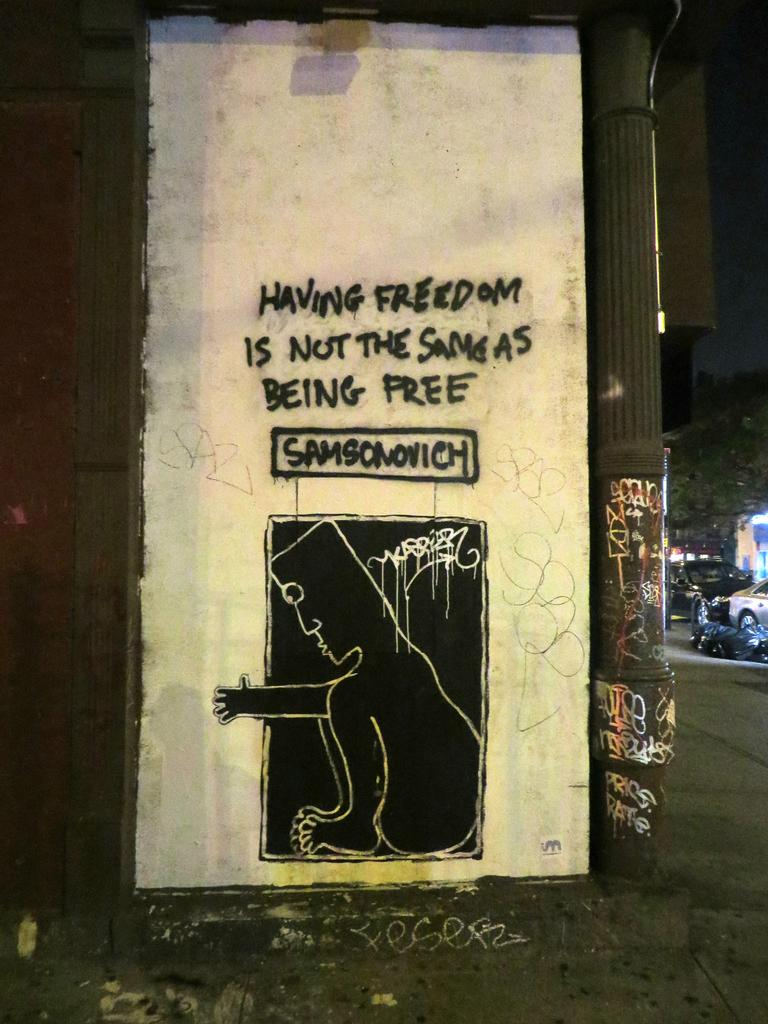<image>
Offer a succinct explanation of the picture presented. Graffiti has been written on the wall that says " Having Freedom Is Not The Same As Being Free" 